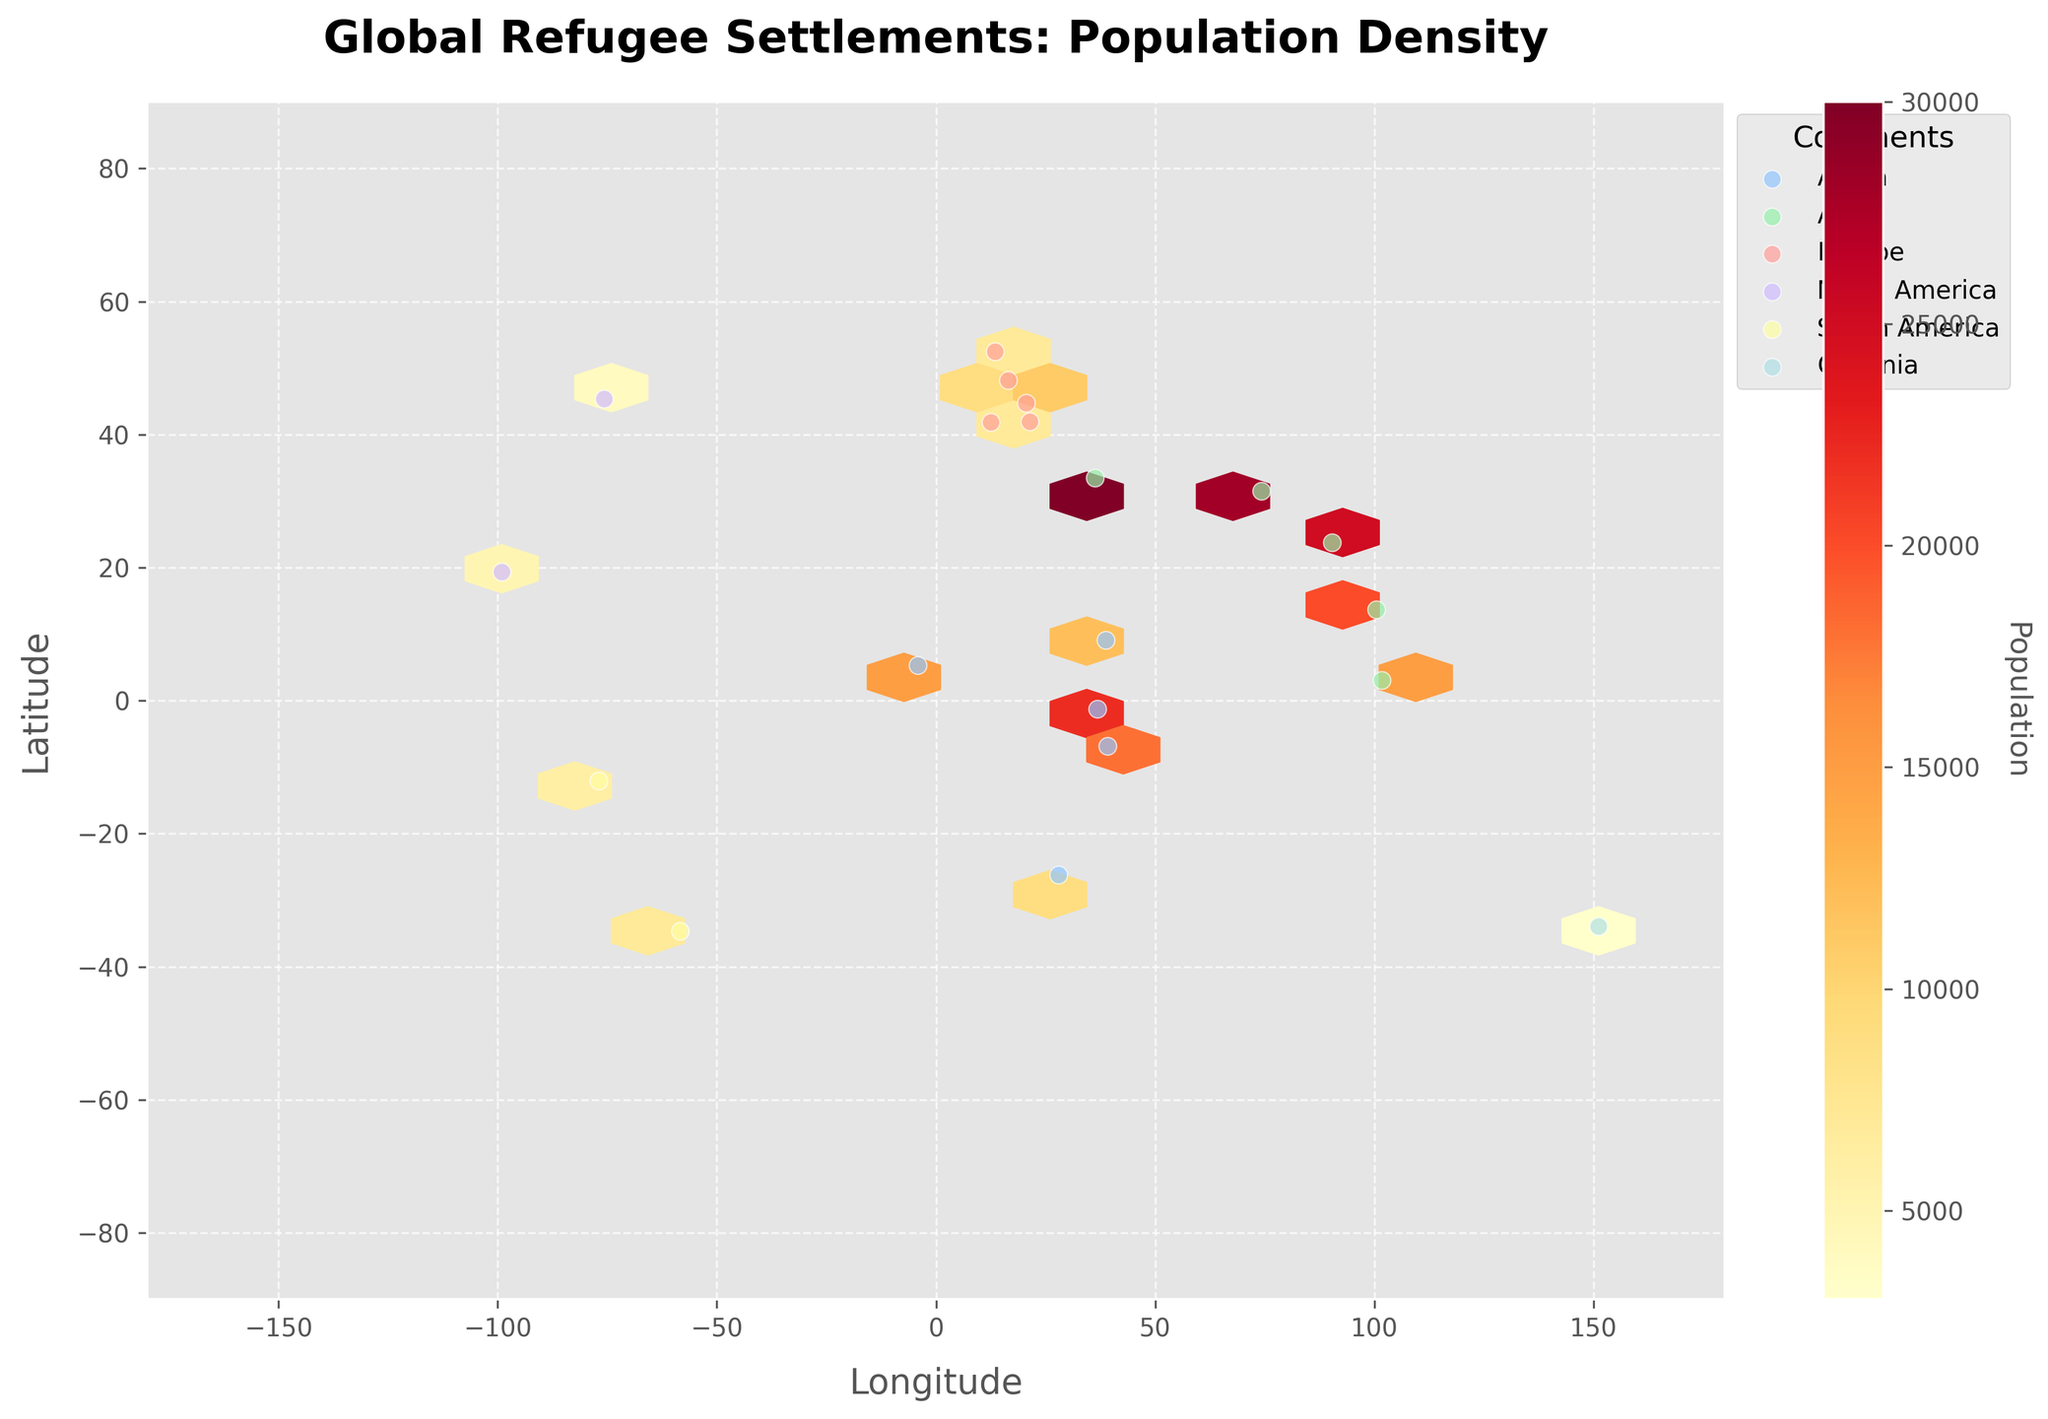What is the title of the figure? The title is given at the top of the figure, which is "Global Refugee Settlements: Population Density".
Answer: Global Refugee Settlements: Population Density What do the hexagonal bins represent in this plot? The hexagonal bins show the density of the refugee population, where color intensity indicates the variation in population density. The brighter and more saturated the color, the higher the population density.
Answer: Population density Which continent has the highest number of refugee settlements according to the scatter points? By looking at the scatter points labeled for each continent on the map, we can see that Asia has a higher number of settlement points compared to other continents.
Answer: Asia What is the color map used for the hexbin plot and what does it indicate? The color map used is 'YlOrRd', which stands for yellow to red. This color scheme indicates increasing population density from yellow (lower density) to red (higher density).
Answer: YlOrRd indicating population density Which continent has the highest population density in a specific region as shown by the hexbin color map? The hexbin color map shows the brightest and most saturated colors around the Middle East and South Asia regions, indicating that Asia has the highest population density in these regions.
Answer: Asia What is the latitude and longitude range covered by the plot? The x-axis range (longitude) is from -180 to 180 degrees, and the y-axis range (latitude) is from -90 to 90 degrees, as shown by the axis limits.
Answer: Longitude: -180 to 180, Latitude: -90 to 90 Which continent appears to have the smallest refugee population settlements based on scatter point sizes? Oceania, based on the scatter point size and number, appears to have the smallest settlements, with the least number of points and smaller sizes.
Answer: Oceania How does the population density in Europe compare to that in Africa? From the hexbin plot, the color intensity in Europe is generally less saturated (lighter) compared to some regions in Africa, indicating that certain areas in Africa have higher population density than Europe.
Answer: Africa has higher population density in certain areas What is the total number of continents shown in the figure? By counting the number of unique continent labels (data points) along with the legend, we see there are six continent labels: Africa, Asia, Europe, North America, South America, and Oceania.
Answer: Six Which specific region on the map has the most scattered refugee settlements based on the scatter points? The scatter points are denser around the regions of Africa and Asia, particularly around the coordinates of central and eastern Africa and South Asia.
Answer: Central and Eastern Africa, South Asia 